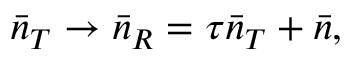<formula> <loc_0><loc_0><loc_500><loc_500>\bar { n } _ { T } \rightarrow \bar { n } _ { R } = \tau \bar { n } _ { T } + \bar { n } ,</formula> 